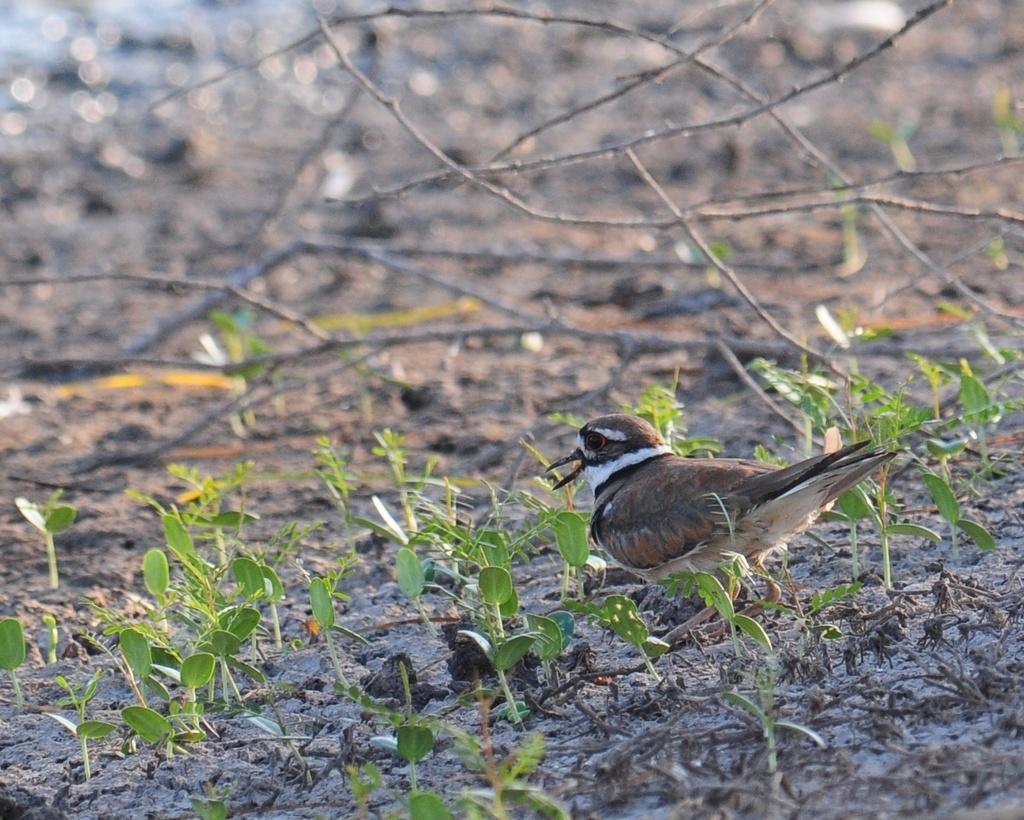What can be seen in the foreground of the picture? There are plants, land, and a bird in the foreground of the picture. What is present in the background of the picture? There are twigs and land in the background of the picture. Can you describe the top part of the image? The top part of the image is blurred. How many kittens are playing with the machine in the background of the image? There are no kittens or machines present in the image. What sound does the whistle make in the foreground of the image? There is no whistle present in the image. 